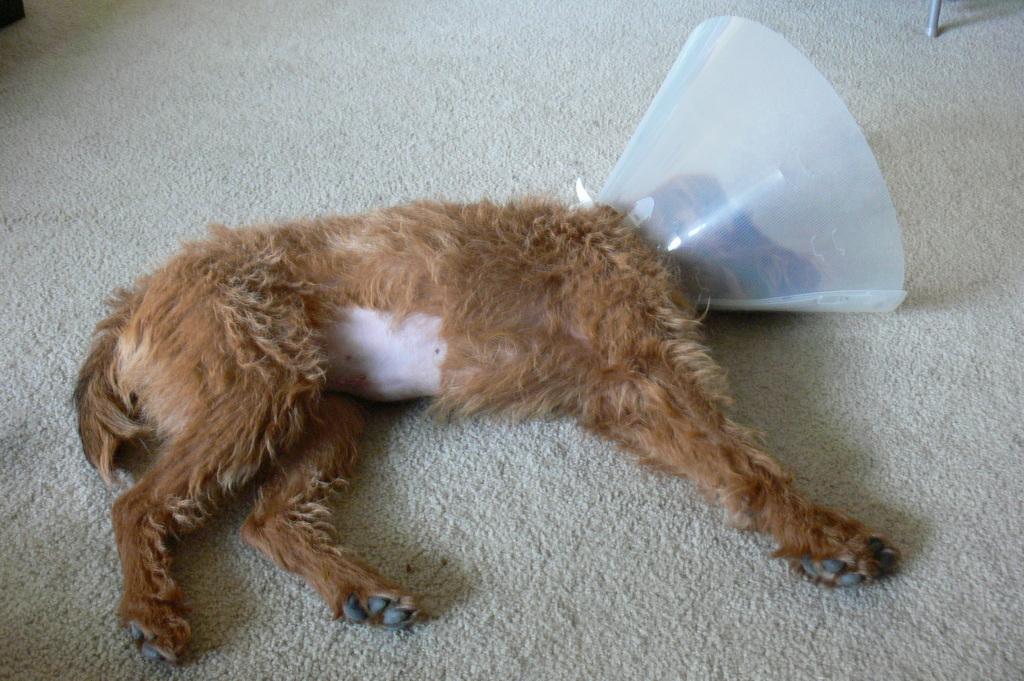Could you give a brief overview of what you see in this image? In the background we can see the objects. In this picture we can see a dog sleeping on the floor carpet and we can see an object around its head part. 